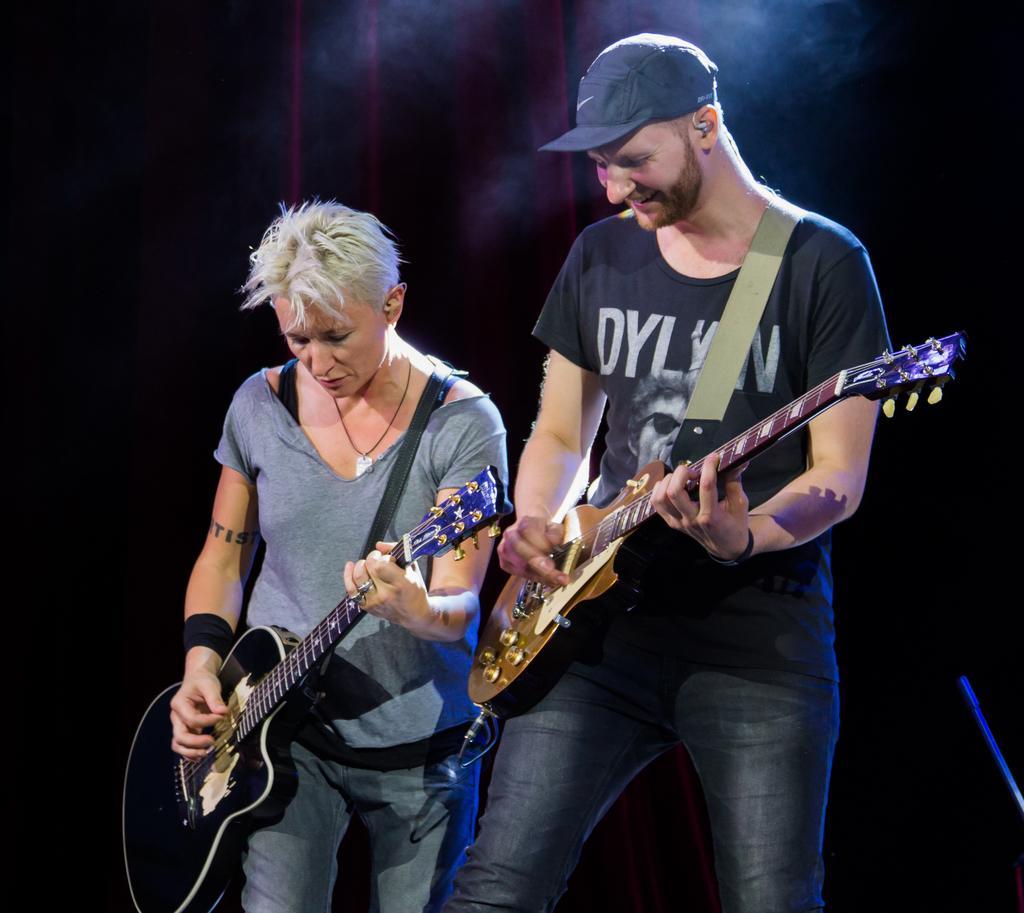Could you give a brief overview of what you see in this image? It looks like a music concert, there are two people one man and one woman. Both of them are playing guitar in the background there is a red color cloth and half of the background is black color. 